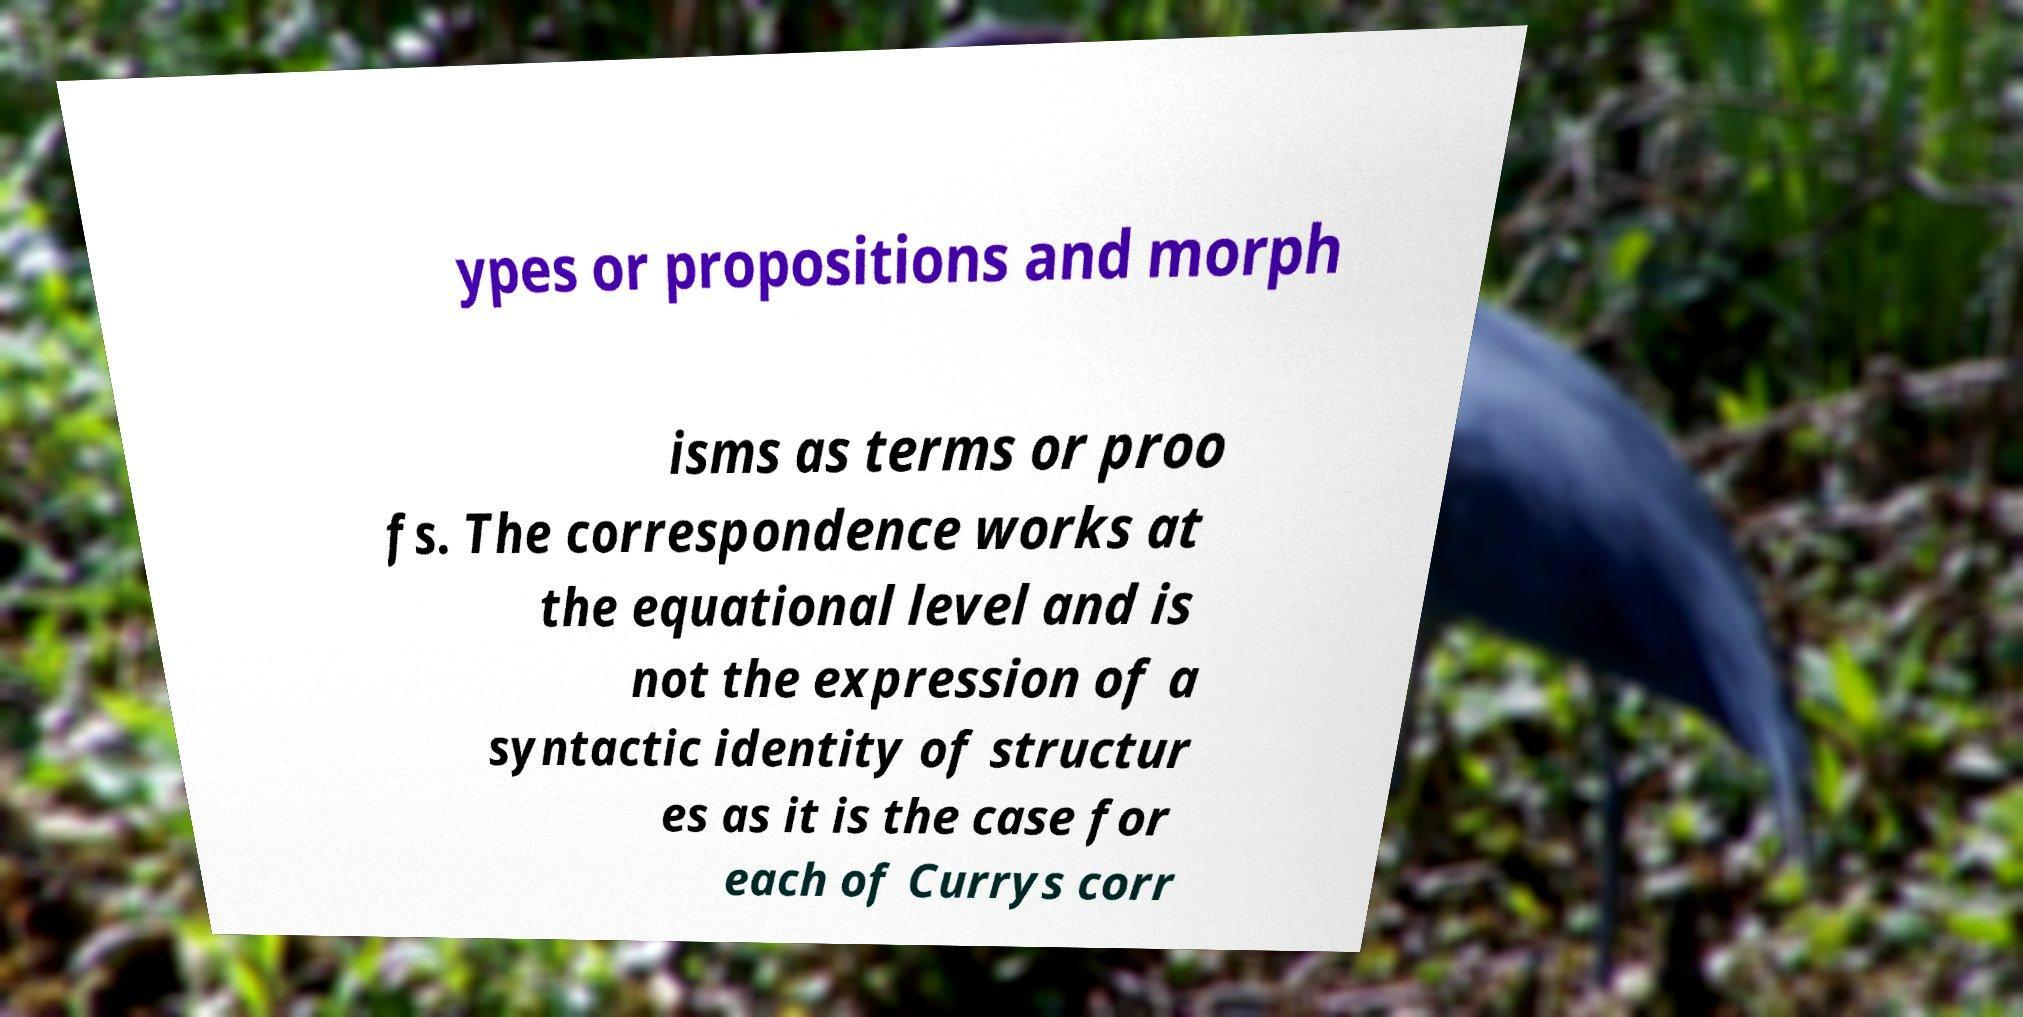What messages or text are displayed in this image? I need them in a readable, typed format. ypes or propositions and morph isms as terms or proo fs. The correspondence works at the equational level and is not the expression of a syntactic identity of structur es as it is the case for each of Currys corr 